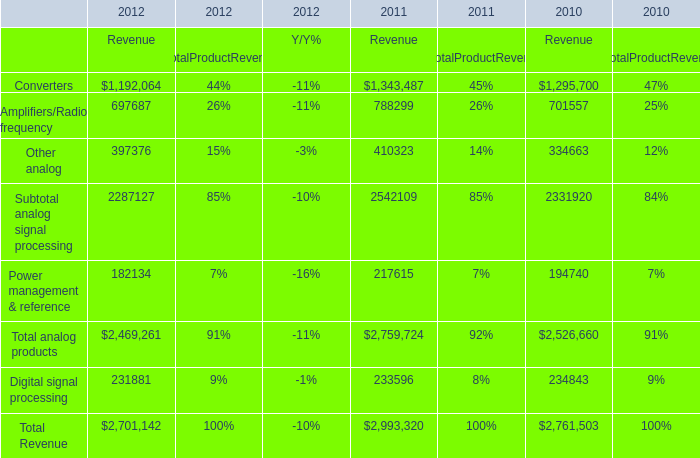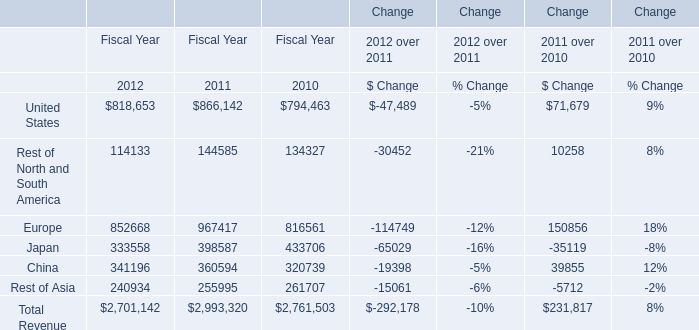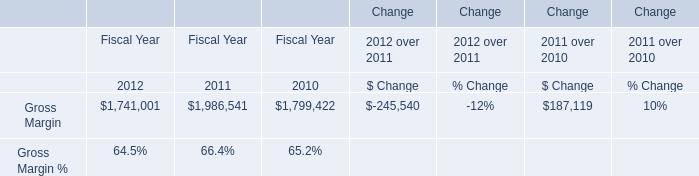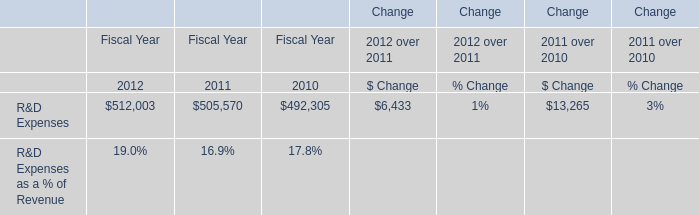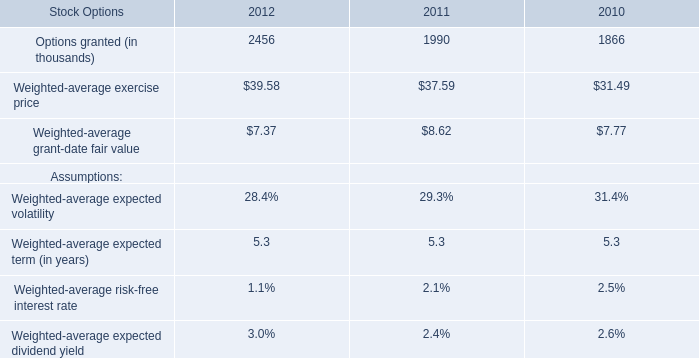What's the average of Converters and Amplifiers/Radio frequency in 2012? 
Computations: ((1192064 + 697687) / 2)
Answer: 944875.5. 